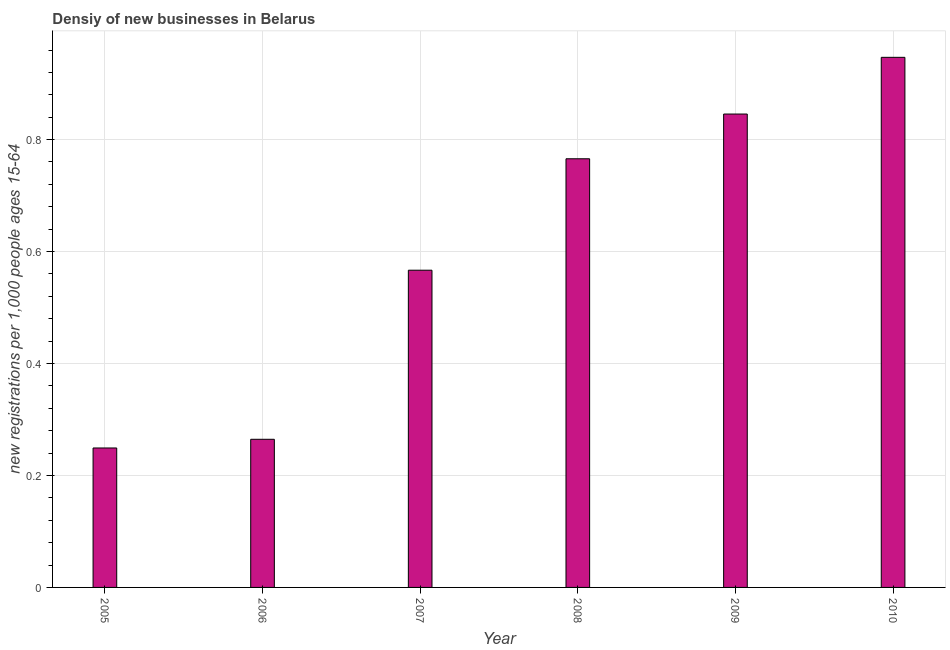Does the graph contain any zero values?
Give a very brief answer. No. What is the title of the graph?
Offer a very short reply. Densiy of new businesses in Belarus. What is the label or title of the X-axis?
Keep it short and to the point. Year. What is the label or title of the Y-axis?
Your response must be concise. New registrations per 1,0 people ages 15-64. What is the density of new business in 2006?
Your answer should be very brief. 0.26. Across all years, what is the maximum density of new business?
Your answer should be compact. 0.95. Across all years, what is the minimum density of new business?
Offer a very short reply. 0.25. In which year was the density of new business minimum?
Ensure brevity in your answer.  2005. What is the sum of the density of new business?
Your answer should be very brief. 3.64. What is the difference between the density of new business in 2005 and 2008?
Keep it short and to the point. -0.52. What is the average density of new business per year?
Your answer should be very brief. 0.61. What is the median density of new business?
Make the answer very short. 0.67. In how many years, is the density of new business greater than 0.28 ?
Offer a very short reply. 4. Do a majority of the years between 2007 and 2005 (inclusive) have density of new business greater than 0.76 ?
Your answer should be very brief. Yes. What is the ratio of the density of new business in 2006 to that in 2007?
Offer a very short reply. 0.47. Is the difference between the density of new business in 2007 and 2009 greater than the difference between any two years?
Provide a short and direct response. No. What is the difference between the highest and the second highest density of new business?
Your answer should be compact. 0.1. How many bars are there?
Offer a terse response. 6. Are all the bars in the graph horizontal?
Ensure brevity in your answer.  No. How many years are there in the graph?
Your answer should be very brief. 6. What is the new registrations per 1,000 people ages 15-64 in 2005?
Offer a very short reply. 0.25. What is the new registrations per 1,000 people ages 15-64 in 2006?
Offer a very short reply. 0.26. What is the new registrations per 1,000 people ages 15-64 in 2007?
Give a very brief answer. 0.57. What is the new registrations per 1,000 people ages 15-64 in 2008?
Your answer should be very brief. 0.77. What is the new registrations per 1,000 people ages 15-64 of 2009?
Your answer should be very brief. 0.85. What is the new registrations per 1,000 people ages 15-64 of 2010?
Keep it short and to the point. 0.95. What is the difference between the new registrations per 1,000 people ages 15-64 in 2005 and 2006?
Give a very brief answer. -0.02. What is the difference between the new registrations per 1,000 people ages 15-64 in 2005 and 2007?
Your answer should be compact. -0.32. What is the difference between the new registrations per 1,000 people ages 15-64 in 2005 and 2008?
Ensure brevity in your answer.  -0.52. What is the difference between the new registrations per 1,000 people ages 15-64 in 2005 and 2009?
Provide a succinct answer. -0.6. What is the difference between the new registrations per 1,000 people ages 15-64 in 2005 and 2010?
Offer a very short reply. -0.7. What is the difference between the new registrations per 1,000 people ages 15-64 in 2006 and 2007?
Your answer should be compact. -0.3. What is the difference between the new registrations per 1,000 people ages 15-64 in 2006 and 2008?
Provide a short and direct response. -0.5. What is the difference between the new registrations per 1,000 people ages 15-64 in 2006 and 2009?
Your answer should be compact. -0.58. What is the difference between the new registrations per 1,000 people ages 15-64 in 2006 and 2010?
Your answer should be compact. -0.68. What is the difference between the new registrations per 1,000 people ages 15-64 in 2007 and 2008?
Offer a terse response. -0.2. What is the difference between the new registrations per 1,000 people ages 15-64 in 2007 and 2009?
Offer a very short reply. -0.28. What is the difference between the new registrations per 1,000 people ages 15-64 in 2007 and 2010?
Make the answer very short. -0.38. What is the difference between the new registrations per 1,000 people ages 15-64 in 2008 and 2009?
Offer a terse response. -0.08. What is the difference between the new registrations per 1,000 people ages 15-64 in 2008 and 2010?
Provide a short and direct response. -0.18. What is the difference between the new registrations per 1,000 people ages 15-64 in 2009 and 2010?
Offer a terse response. -0.1. What is the ratio of the new registrations per 1,000 people ages 15-64 in 2005 to that in 2006?
Make the answer very short. 0.94. What is the ratio of the new registrations per 1,000 people ages 15-64 in 2005 to that in 2007?
Offer a terse response. 0.44. What is the ratio of the new registrations per 1,000 people ages 15-64 in 2005 to that in 2008?
Offer a terse response. 0.33. What is the ratio of the new registrations per 1,000 people ages 15-64 in 2005 to that in 2009?
Provide a short and direct response. 0.29. What is the ratio of the new registrations per 1,000 people ages 15-64 in 2005 to that in 2010?
Make the answer very short. 0.26. What is the ratio of the new registrations per 1,000 people ages 15-64 in 2006 to that in 2007?
Your answer should be compact. 0.47. What is the ratio of the new registrations per 1,000 people ages 15-64 in 2006 to that in 2008?
Offer a very short reply. 0.35. What is the ratio of the new registrations per 1,000 people ages 15-64 in 2006 to that in 2009?
Your response must be concise. 0.31. What is the ratio of the new registrations per 1,000 people ages 15-64 in 2006 to that in 2010?
Provide a short and direct response. 0.28. What is the ratio of the new registrations per 1,000 people ages 15-64 in 2007 to that in 2008?
Offer a terse response. 0.74. What is the ratio of the new registrations per 1,000 people ages 15-64 in 2007 to that in 2009?
Offer a very short reply. 0.67. What is the ratio of the new registrations per 1,000 people ages 15-64 in 2007 to that in 2010?
Your response must be concise. 0.6. What is the ratio of the new registrations per 1,000 people ages 15-64 in 2008 to that in 2009?
Ensure brevity in your answer.  0.91. What is the ratio of the new registrations per 1,000 people ages 15-64 in 2008 to that in 2010?
Provide a short and direct response. 0.81. What is the ratio of the new registrations per 1,000 people ages 15-64 in 2009 to that in 2010?
Keep it short and to the point. 0.89. 